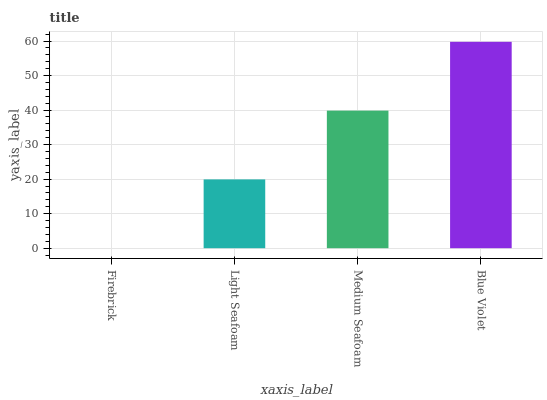Is Firebrick the minimum?
Answer yes or no. Yes. Is Blue Violet the maximum?
Answer yes or no. Yes. Is Light Seafoam the minimum?
Answer yes or no. No. Is Light Seafoam the maximum?
Answer yes or no. No. Is Light Seafoam greater than Firebrick?
Answer yes or no. Yes. Is Firebrick less than Light Seafoam?
Answer yes or no. Yes. Is Firebrick greater than Light Seafoam?
Answer yes or no. No. Is Light Seafoam less than Firebrick?
Answer yes or no. No. Is Medium Seafoam the high median?
Answer yes or no. Yes. Is Light Seafoam the low median?
Answer yes or no. Yes. Is Firebrick the high median?
Answer yes or no. No. Is Firebrick the low median?
Answer yes or no. No. 